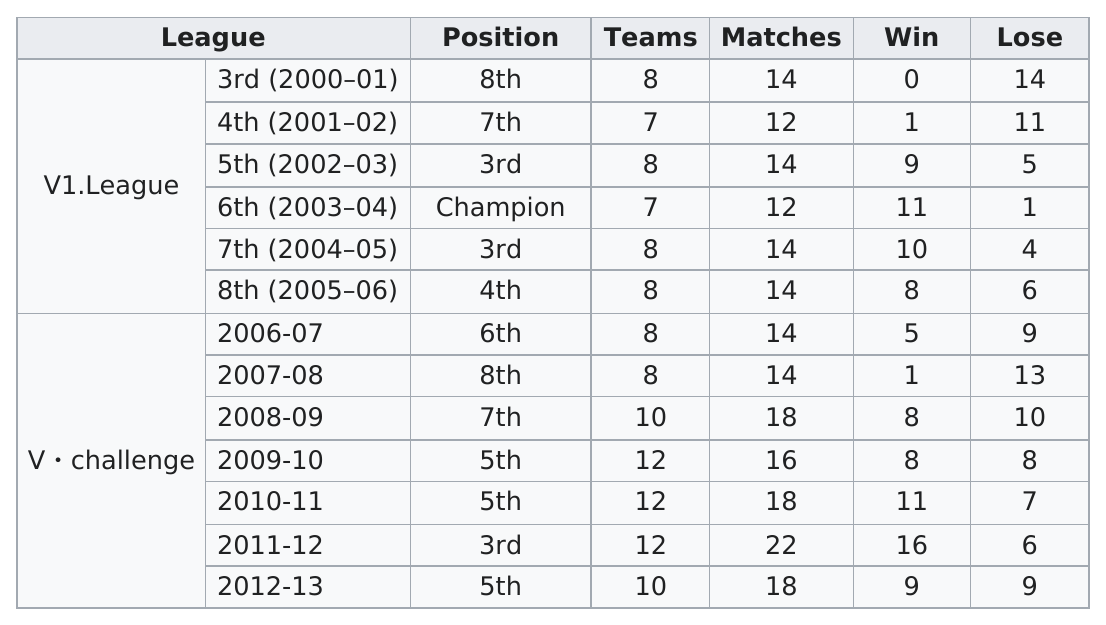Give some essential details in this illustration. The team's position in the 2000-2001 league year was not sixth, but rather eighth. They won at least 10 games in four seasons. In the 2006-2007 season, this team lost a total of 9 games. The most matches were recorded in the years 2011-12. In the 2006-2007 season, there were 8 teams participating. 